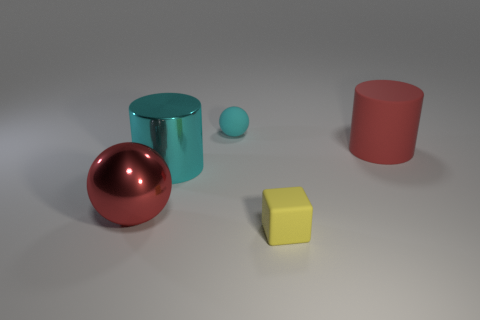What is the color of the large thing that is both behind the big red metal sphere and to the left of the tiny yellow thing?
Your answer should be very brief. Cyan. There is a metallic object that is to the right of the red object that is on the left side of the big red cylinder; how big is it?
Offer a very short reply. Large. Are there any large rubber cylinders that have the same color as the tiny ball?
Offer a very short reply. No. Are there an equal number of cyan metal cylinders on the right side of the small yellow thing and small cyan matte things?
Provide a succinct answer. No. What number of big cyan metallic things are there?
Ensure brevity in your answer.  1. What is the shape of the thing that is in front of the metallic cylinder and on the right side of the large red sphere?
Your answer should be compact. Cube. Do the ball in front of the big red cylinder and the small ball to the left of the tiny yellow rubber object have the same color?
Offer a very short reply. No. What size is the thing that is the same color as the metallic cylinder?
Offer a terse response. Small. Are there any green balls made of the same material as the tiny yellow thing?
Keep it short and to the point. No. Are there the same number of cyan rubber balls in front of the small cyan object and rubber balls that are on the left side of the big cyan object?
Your answer should be compact. Yes. 